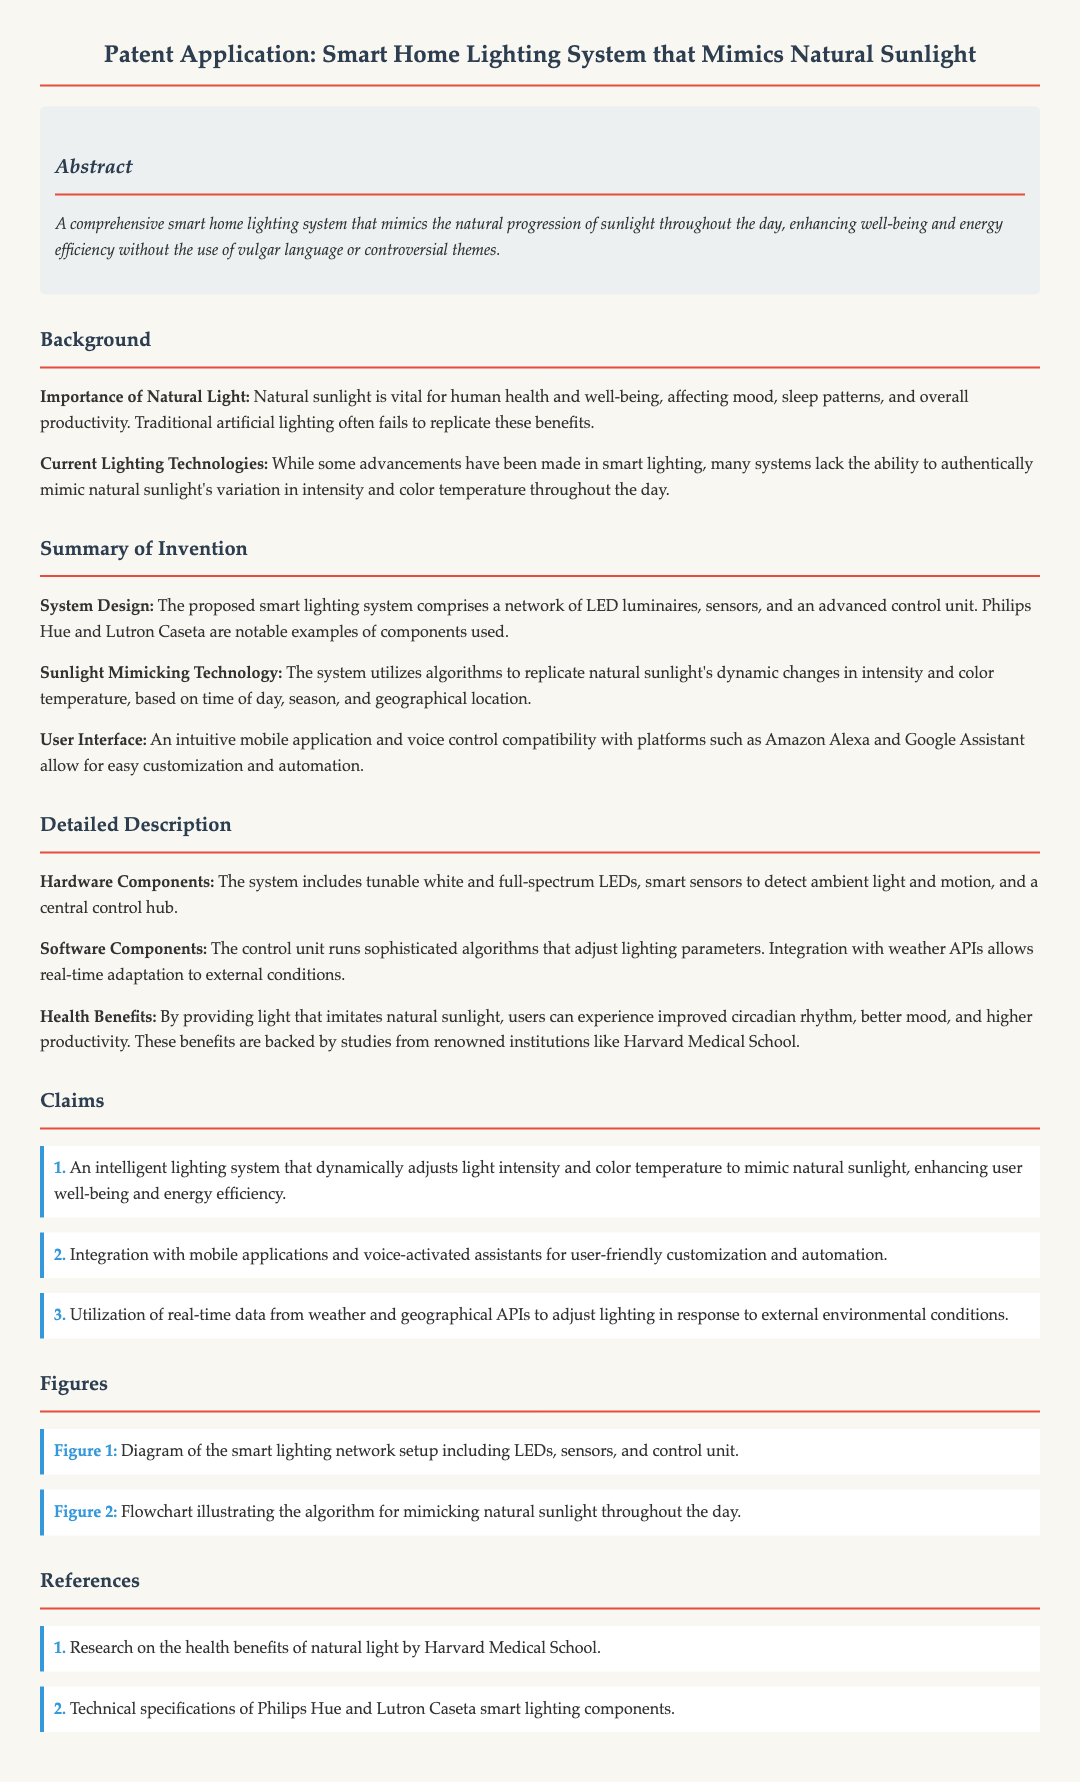What is the purpose of the smart lighting system? The purpose of the smart lighting system is to mimic the natural progression of sunlight throughout the day, enhancing well-being and energy efficiency.
Answer: Mimic natural sunlight What components are included in the hardware design? The hardware design includes tunable white and full-spectrum LEDs, smart sensors, and a central control hub.
Answer: LEDs, sensors, control hub How does the system adapt to external conditions? The system adapts to external conditions by integrating real-time data from weather and geographical APIs.
Answer: Weather and geographical APIs What are the health benefits mentioned in the document? The health benefits mentioned include improved circadian rhythm, better mood, and higher productivity.
Answer: Improved circadian rhythm, better mood, higher productivity Which mobile platforms can the user interface be customized with? The user interface can be customized with platforms such as Amazon Alexa and Google Assistant.
Answer: Amazon Alexa and Google Assistant Who conducted studies backing the health benefits of natural light? Studies backing the health benefits of natural light were conducted by Harvard Medical School.
Answer: Harvard Medical School What is the first claim of the patent? The first claim of the patent is about an intelligent lighting system that dynamically adjusts light intensity and color temperature.
Answer: Intelligent lighting system adjusts light intensity and color temperature What is shown in Figure 1? Figure 1 shows a diagram of the smart lighting network setup including LEDs, sensors, and control unit.
Answer: Smart lighting network setup What type of LEDs does the system utilize? The system utilizes tunable white and full-spectrum LEDs.
Answer: Tunable white and full-spectrum LEDs What does the abstract highlight about the system? The abstract highlights that the system enhances well-being and energy efficiency without the use of vulgar language or controversial themes.
Answer: Enhances well-being and energy efficiency 